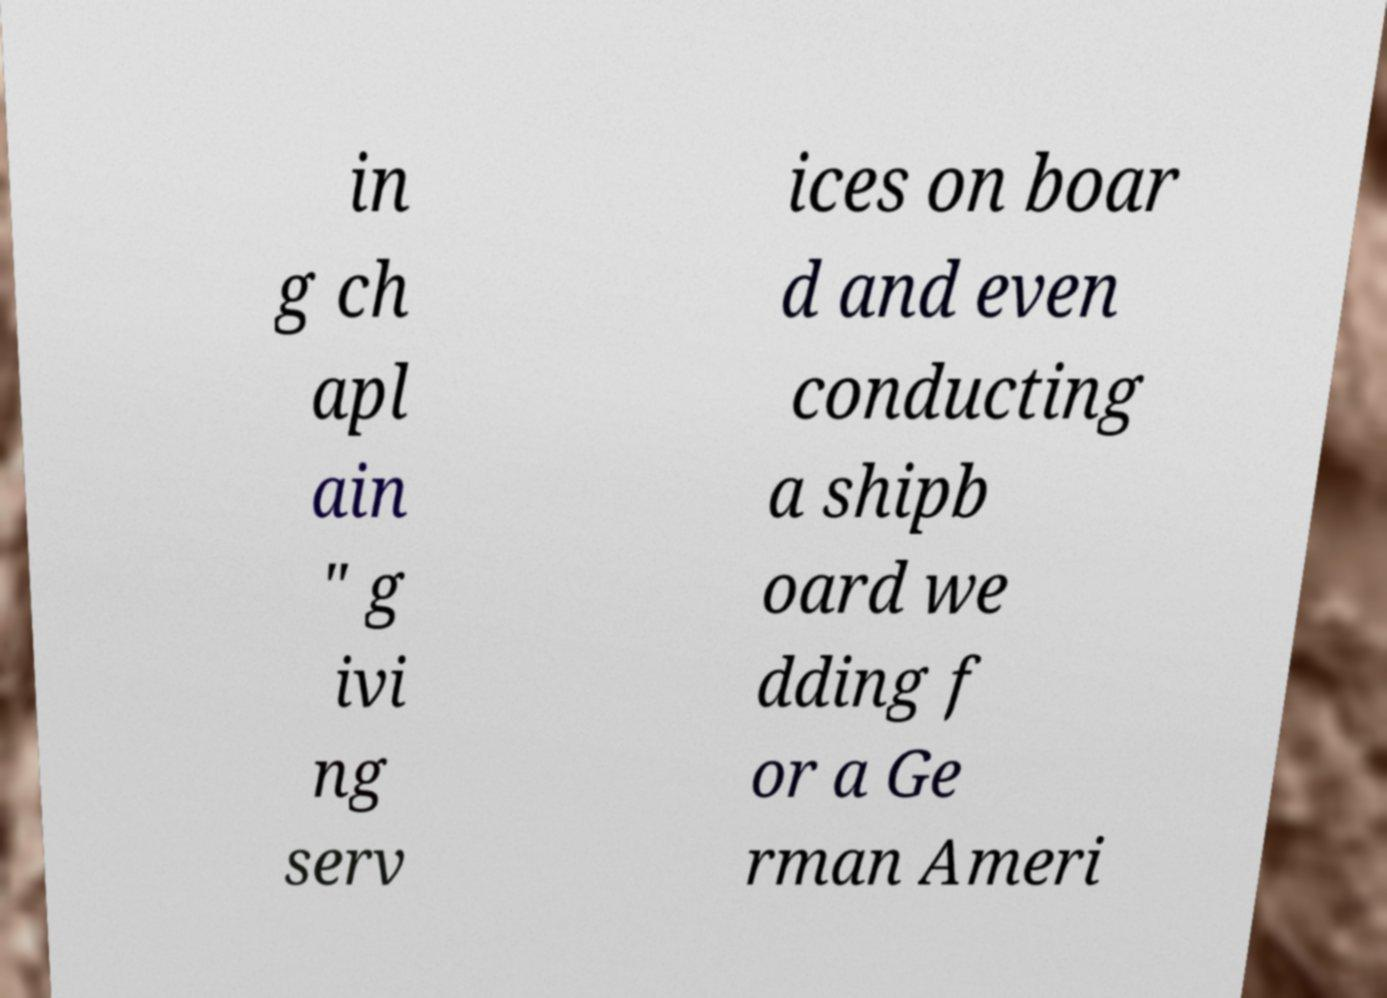Could you assist in decoding the text presented in this image and type it out clearly? in g ch apl ain " g ivi ng serv ices on boar d and even conducting a shipb oard we dding f or a Ge rman Ameri 